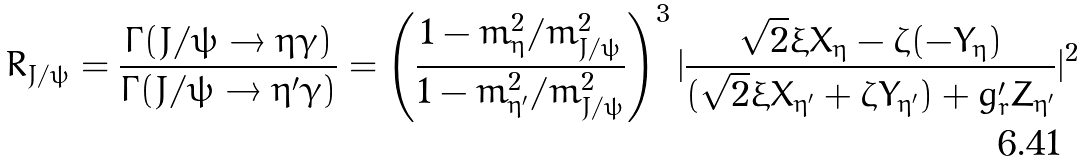<formula> <loc_0><loc_0><loc_500><loc_500>R _ { J / \psi } = \frac { \Gamma ( J / \psi \to \eta \gamma ) } { \Gamma ( J / \psi \to \eta ^ { \prime } \gamma ) } = \left ( \frac { 1 - m _ { \eta } ^ { 2 } / m _ { J / \psi } ^ { 2 } } { 1 - m _ { \eta ^ { \prime } } ^ { 2 } / m _ { J / \psi } ^ { 2 } } \right ) ^ { 3 } | \frac { \sqrt { 2 } \xi X _ { \eta } - \zeta ( - Y _ { \eta } ) } { ( \sqrt { 2 } \xi X _ { \eta ^ { \prime } } + \zeta Y _ { \eta ^ { \prime } } ) + g _ { r } ^ { \prime } Z _ { \eta ^ { \prime } } } | ^ { 2 }</formula> 